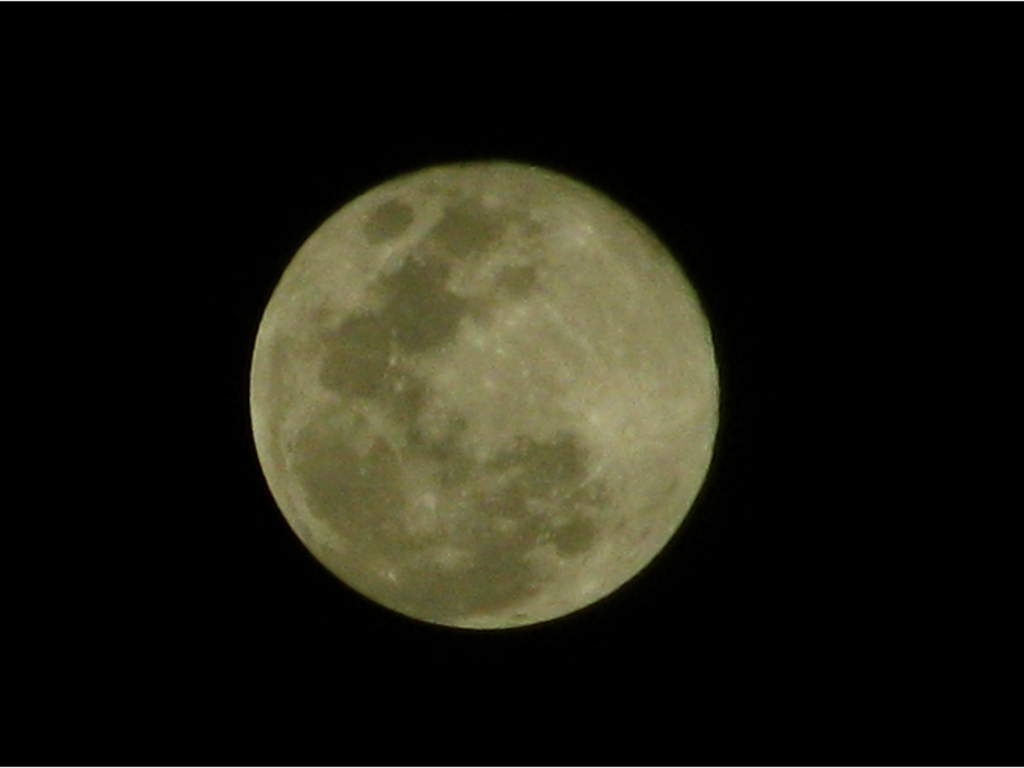Can you tell me more about the features visible on the moon's surface? Certainly! The moon's surface is marked by a diverse array of features, including impact craters of various sizes, which resulted from collisions with meteoroids and comets. The dark flat regions, known as maria, are vast plains formed by ancient volcanic eruptions. You can also spot brighter highland areas, which are older, heavily cratered, and higher in elevation. What's the significance of seeing the moon in its full phase? A full moon occurs when the moon is on the opposite side of the Earth from the sun, and it's significant because it illuminates the night sky with its fullest and brightest appearance. It has cultural significance in many societies, influences the Earth's tides due to gravitational pull, and offers a great opportunity for astronomers and enthusiasts to study its surface features in detail. 